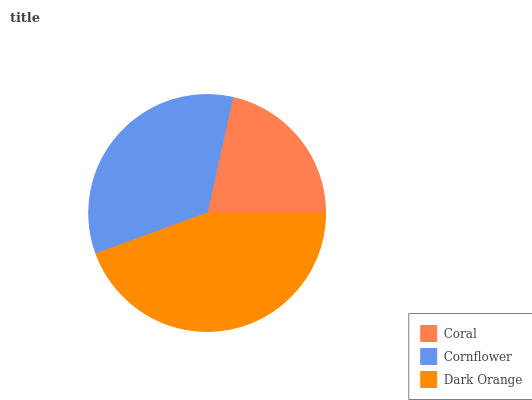Is Coral the minimum?
Answer yes or no. Yes. Is Dark Orange the maximum?
Answer yes or no. Yes. Is Cornflower the minimum?
Answer yes or no. No. Is Cornflower the maximum?
Answer yes or no. No. Is Cornflower greater than Coral?
Answer yes or no. Yes. Is Coral less than Cornflower?
Answer yes or no. Yes. Is Coral greater than Cornflower?
Answer yes or no. No. Is Cornflower less than Coral?
Answer yes or no. No. Is Cornflower the high median?
Answer yes or no. Yes. Is Cornflower the low median?
Answer yes or no. Yes. Is Dark Orange the high median?
Answer yes or no. No. Is Coral the low median?
Answer yes or no. No. 